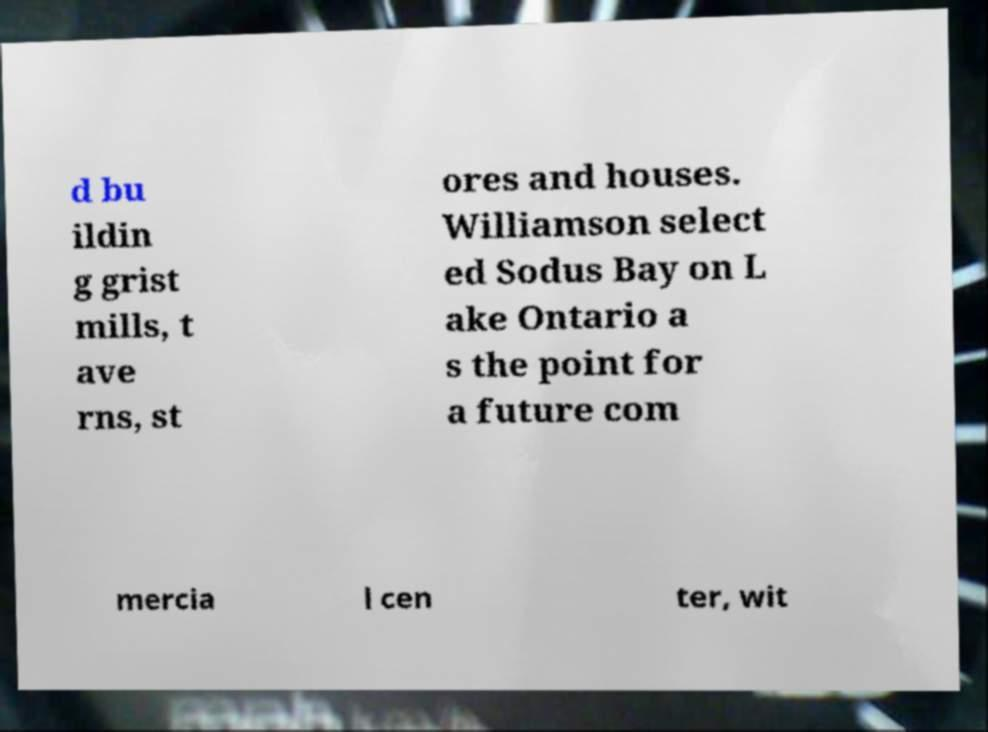Could you assist in decoding the text presented in this image and type it out clearly? d bu ildin g grist mills, t ave rns, st ores and houses. Williamson select ed Sodus Bay on L ake Ontario a s the point for a future com mercia l cen ter, wit 